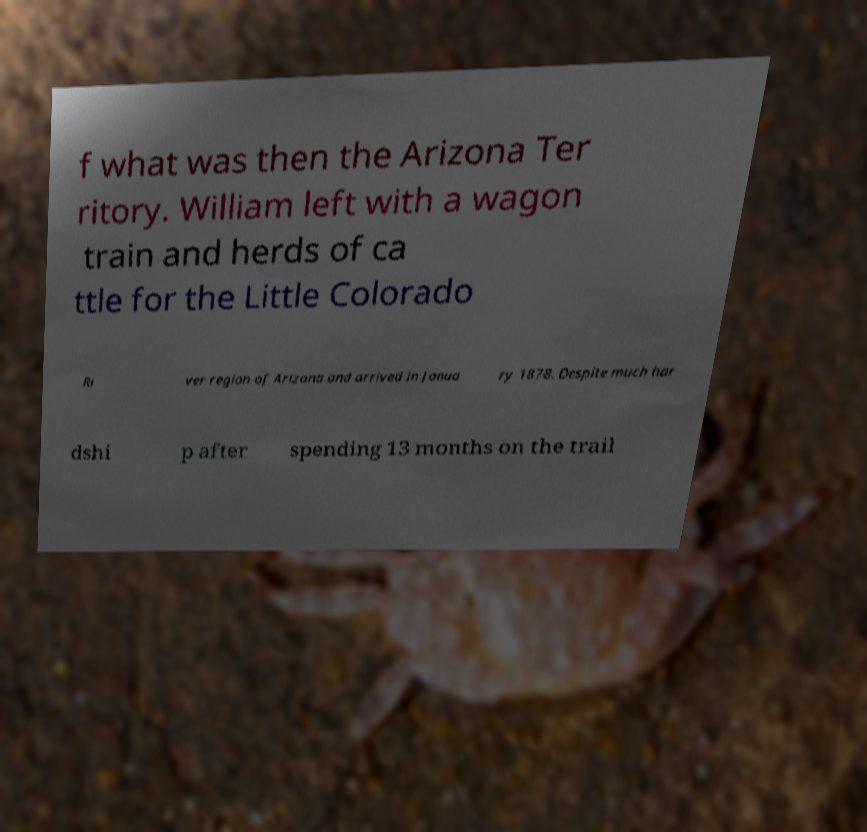Can you accurately transcribe the text from the provided image for me? f what was then the Arizona Ter ritory. William left with a wagon train and herds of ca ttle for the Little Colorado Ri ver region of Arizona and arrived in Janua ry 1878. Despite much har dshi p after spending 13 months on the trail 